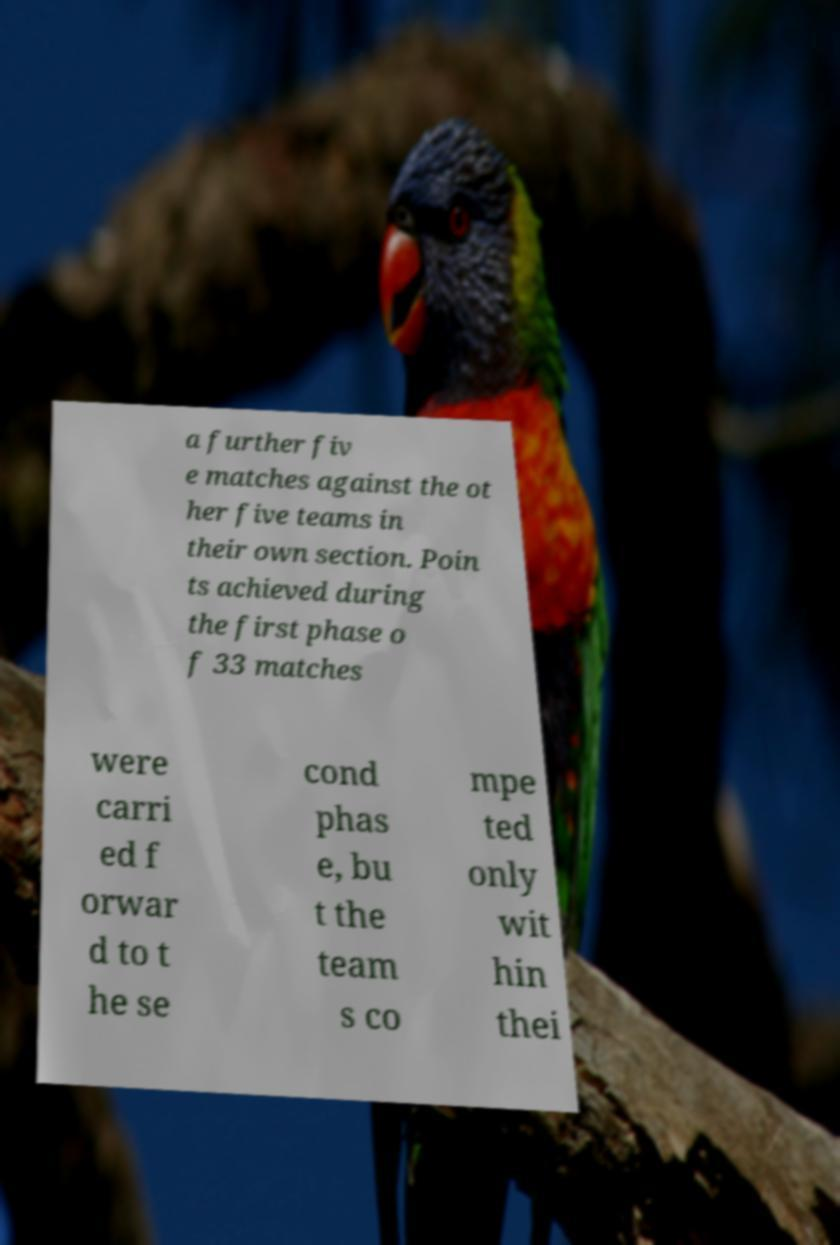What messages or text are displayed in this image? I need them in a readable, typed format. a further fiv e matches against the ot her five teams in their own section. Poin ts achieved during the first phase o f 33 matches were carri ed f orwar d to t he se cond phas e, bu t the team s co mpe ted only wit hin thei 